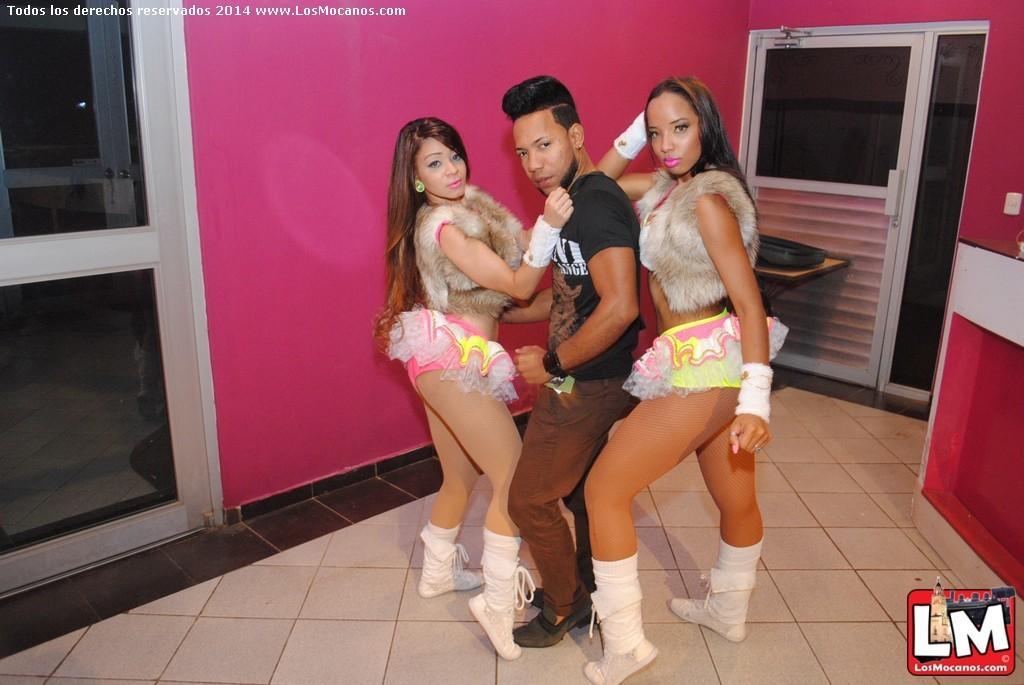Describe this image in one or two sentences. There is a man and two women standing. In the back there is a wall and doors. There are watermarks in the top left and bottom right corners. 